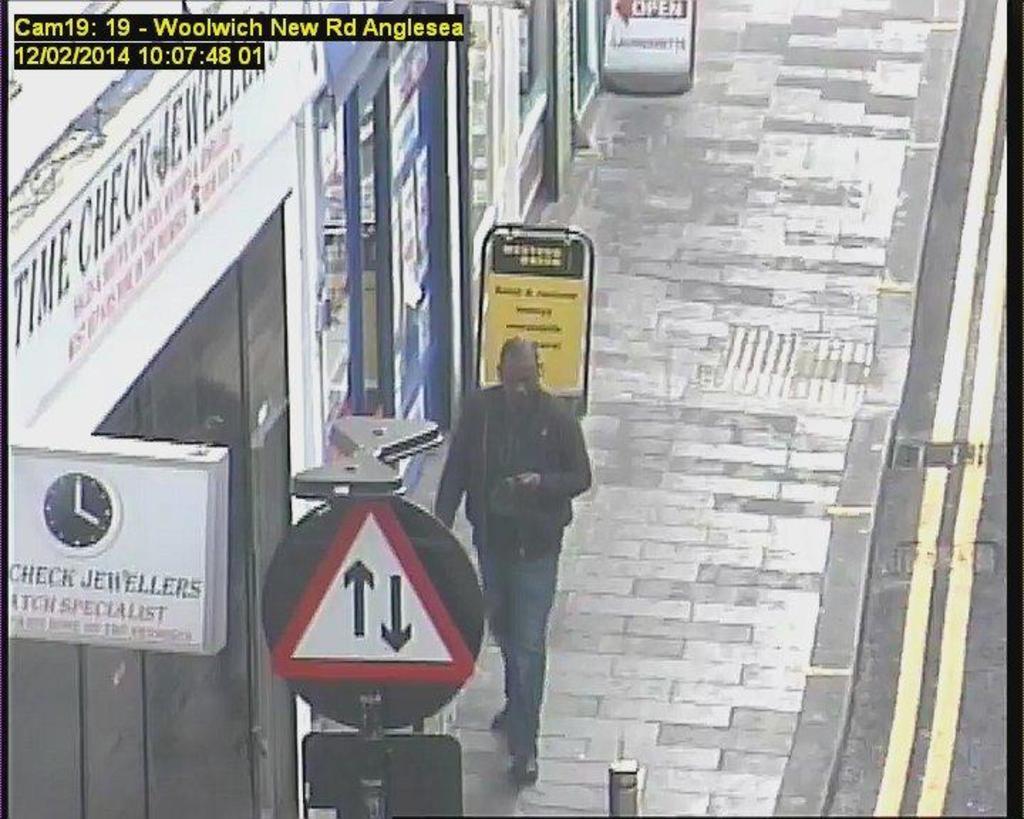How would you summarize this image in a sentence or two? In this picture we can see a man, he is walking on the pathway, beside to him we can find few sign boards and few stores. 